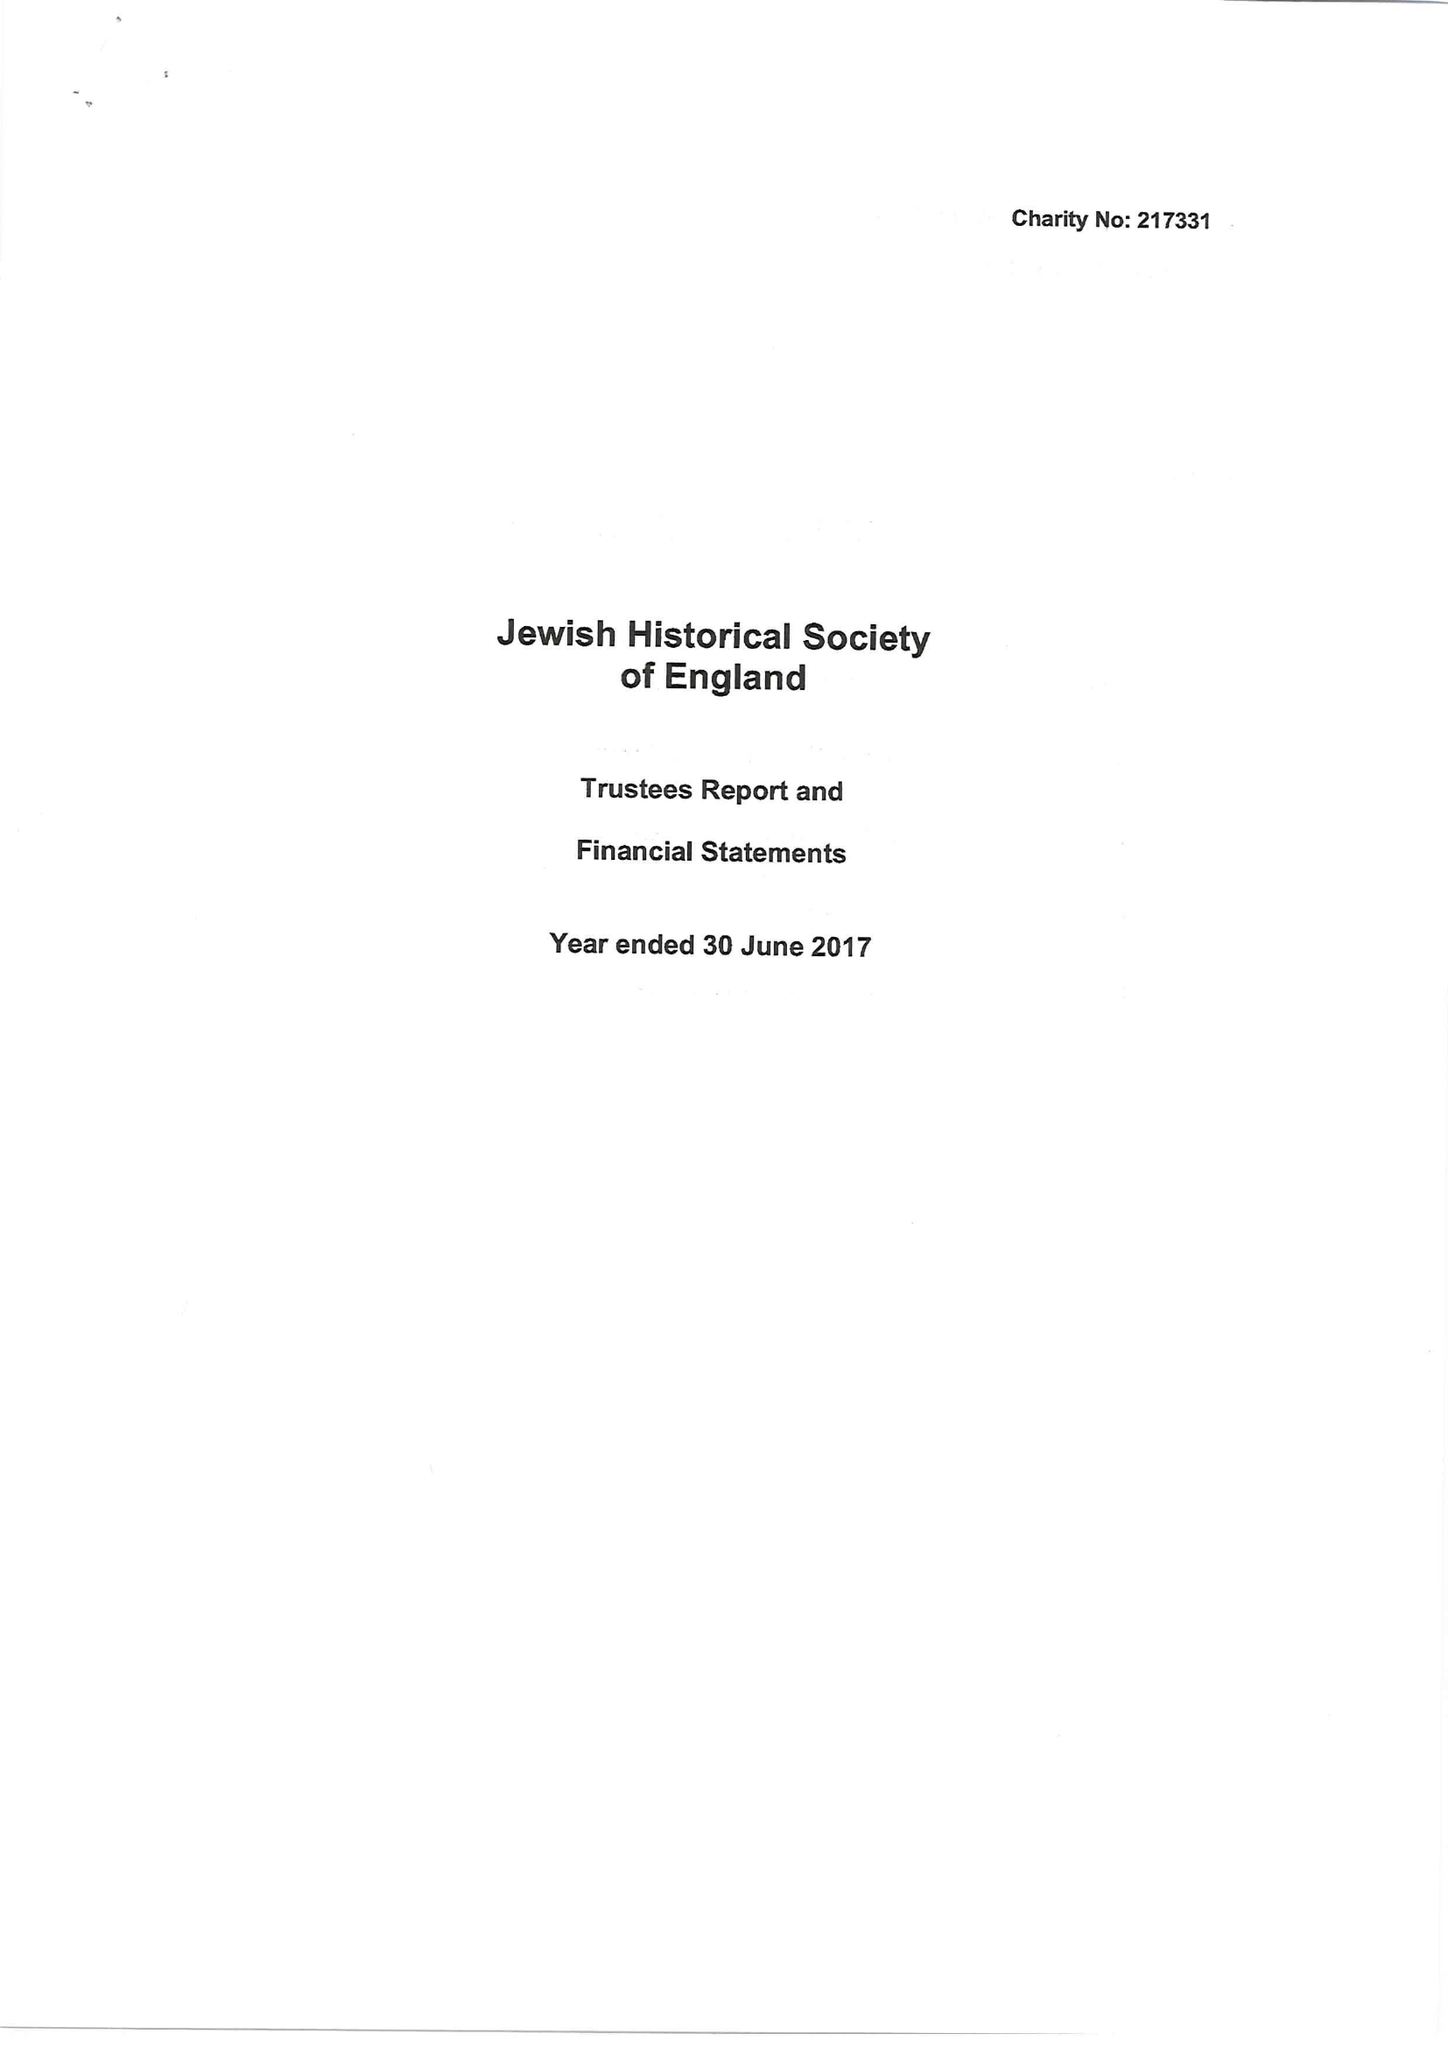What is the value for the address__postcode?
Answer the question using a single word or phrase. PE32 1SF 